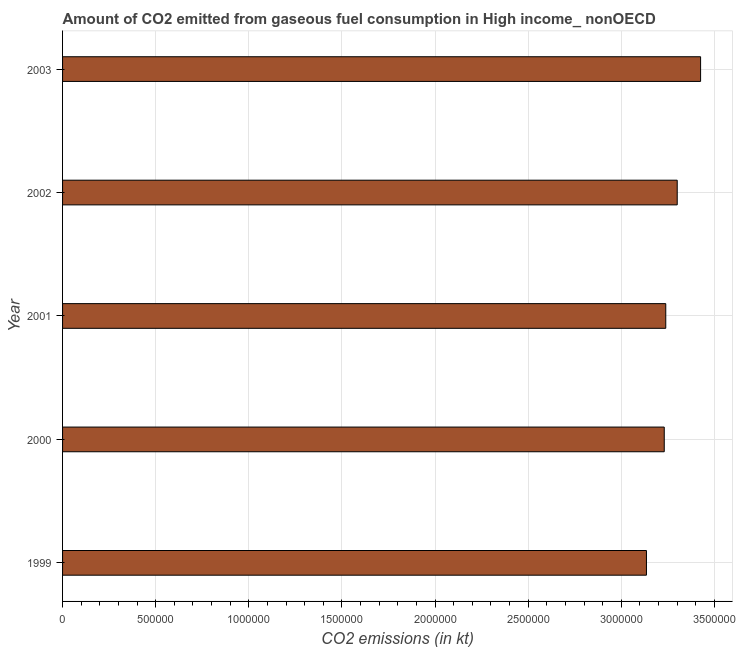Does the graph contain grids?
Provide a short and direct response. Yes. What is the title of the graph?
Make the answer very short. Amount of CO2 emitted from gaseous fuel consumption in High income_ nonOECD. What is the label or title of the X-axis?
Keep it short and to the point. CO2 emissions (in kt). What is the label or title of the Y-axis?
Offer a terse response. Year. What is the co2 emissions from gaseous fuel consumption in 2000?
Your answer should be very brief. 3.23e+06. Across all years, what is the maximum co2 emissions from gaseous fuel consumption?
Your answer should be very brief. 3.43e+06. Across all years, what is the minimum co2 emissions from gaseous fuel consumption?
Ensure brevity in your answer.  3.13e+06. In which year was the co2 emissions from gaseous fuel consumption maximum?
Give a very brief answer. 2003. In which year was the co2 emissions from gaseous fuel consumption minimum?
Offer a very short reply. 1999. What is the sum of the co2 emissions from gaseous fuel consumption?
Make the answer very short. 1.63e+07. What is the difference between the co2 emissions from gaseous fuel consumption in 1999 and 2000?
Offer a terse response. -9.55e+04. What is the average co2 emissions from gaseous fuel consumption per year?
Your answer should be compact. 3.27e+06. What is the median co2 emissions from gaseous fuel consumption?
Provide a short and direct response. 3.24e+06. In how many years, is the co2 emissions from gaseous fuel consumption greater than 2000000 kt?
Keep it short and to the point. 5. What is the ratio of the co2 emissions from gaseous fuel consumption in 2000 to that in 2003?
Make the answer very short. 0.94. Is the difference between the co2 emissions from gaseous fuel consumption in 2000 and 2002 greater than the difference between any two years?
Offer a very short reply. No. What is the difference between the highest and the second highest co2 emissions from gaseous fuel consumption?
Provide a succinct answer. 1.25e+05. Is the sum of the co2 emissions from gaseous fuel consumption in 1999 and 2002 greater than the maximum co2 emissions from gaseous fuel consumption across all years?
Make the answer very short. Yes. What is the difference between the highest and the lowest co2 emissions from gaseous fuel consumption?
Offer a very short reply. 2.91e+05. In how many years, is the co2 emissions from gaseous fuel consumption greater than the average co2 emissions from gaseous fuel consumption taken over all years?
Provide a succinct answer. 2. Are all the bars in the graph horizontal?
Give a very brief answer. Yes. How many years are there in the graph?
Provide a short and direct response. 5. What is the difference between two consecutive major ticks on the X-axis?
Provide a succinct answer. 5.00e+05. Are the values on the major ticks of X-axis written in scientific E-notation?
Make the answer very short. No. What is the CO2 emissions (in kt) in 1999?
Your answer should be compact. 3.13e+06. What is the CO2 emissions (in kt) in 2000?
Your answer should be compact. 3.23e+06. What is the CO2 emissions (in kt) of 2001?
Offer a terse response. 3.24e+06. What is the CO2 emissions (in kt) in 2002?
Give a very brief answer. 3.30e+06. What is the CO2 emissions (in kt) of 2003?
Your answer should be compact. 3.43e+06. What is the difference between the CO2 emissions (in kt) in 1999 and 2000?
Your response must be concise. -9.55e+04. What is the difference between the CO2 emissions (in kt) in 1999 and 2001?
Provide a succinct answer. -1.04e+05. What is the difference between the CO2 emissions (in kt) in 1999 and 2002?
Offer a very short reply. -1.65e+05. What is the difference between the CO2 emissions (in kt) in 1999 and 2003?
Offer a terse response. -2.91e+05. What is the difference between the CO2 emissions (in kt) in 2000 and 2001?
Your answer should be very brief. -8120.8. What is the difference between the CO2 emissions (in kt) in 2000 and 2002?
Ensure brevity in your answer.  -6.96e+04. What is the difference between the CO2 emissions (in kt) in 2000 and 2003?
Keep it short and to the point. -1.95e+05. What is the difference between the CO2 emissions (in kt) in 2001 and 2002?
Give a very brief answer. -6.15e+04. What is the difference between the CO2 emissions (in kt) in 2001 and 2003?
Make the answer very short. -1.87e+05. What is the difference between the CO2 emissions (in kt) in 2002 and 2003?
Provide a succinct answer. -1.25e+05. What is the ratio of the CO2 emissions (in kt) in 1999 to that in 2000?
Make the answer very short. 0.97. What is the ratio of the CO2 emissions (in kt) in 1999 to that in 2001?
Give a very brief answer. 0.97. What is the ratio of the CO2 emissions (in kt) in 1999 to that in 2002?
Give a very brief answer. 0.95. What is the ratio of the CO2 emissions (in kt) in 1999 to that in 2003?
Offer a terse response. 0.92. What is the ratio of the CO2 emissions (in kt) in 2000 to that in 2002?
Your response must be concise. 0.98. What is the ratio of the CO2 emissions (in kt) in 2000 to that in 2003?
Your answer should be compact. 0.94. What is the ratio of the CO2 emissions (in kt) in 2001 to that in 2003?
Provide a succinct answer. 0.94. What is the ratio of the CO2 emissions (in kt) in 2002 to that in 2003?
Your answer should be compact. 0.96. 